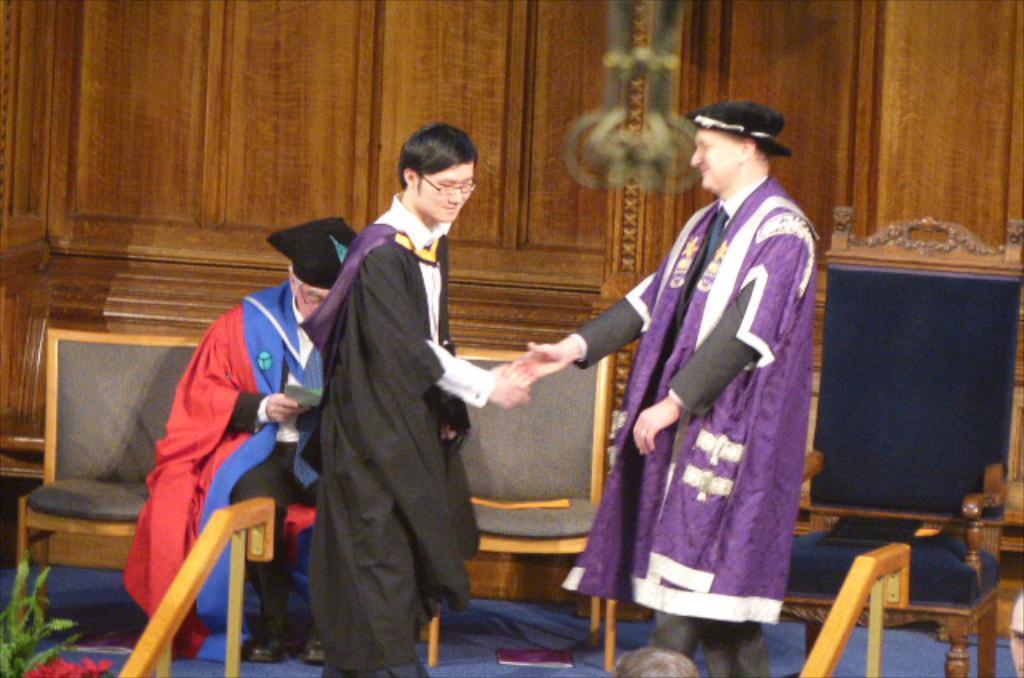Describe this image in one or two sentences. This person in black dress is giving a shake hand to the other person in purple dress. Backside of this person and other man is sitting on a chair and holds paper. Under this chair there is a book. Front this is a plant. 